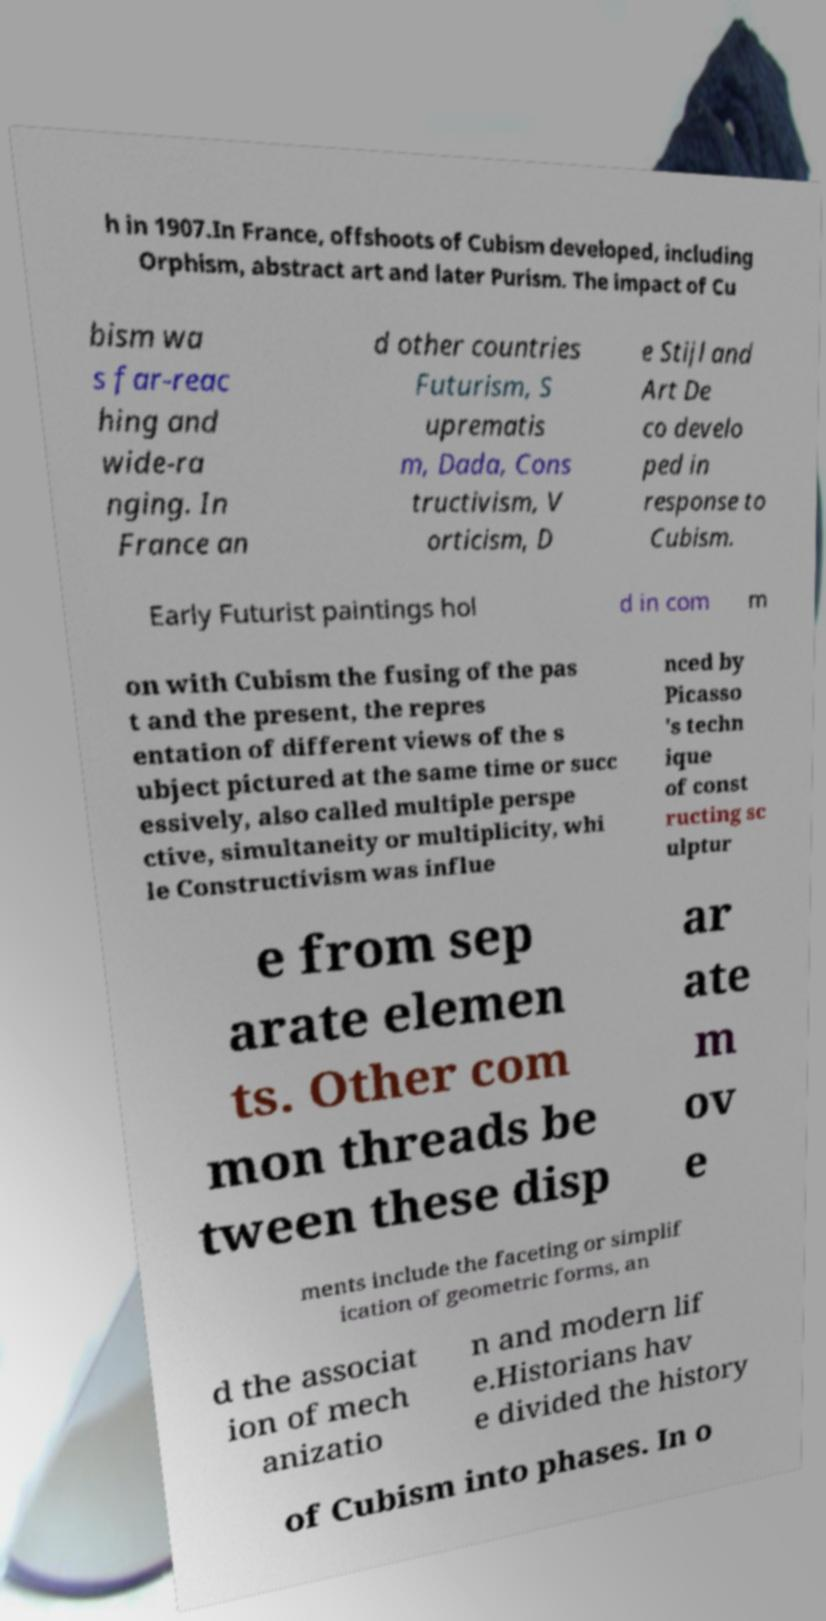Could you extract and type out the text from this image? h in 1907.In France, offshoots of Cubism developed, including Orphism, abstract art and later Purism. The impact of Cu bism wa s far-reac hing and wide-ra nging. In France an d other countries Futurism, S uprematis m, Dada, Cons tructivism, V orticism, D e Stijl and Art De co develo ped in response to Cubism. Early Futurist paintings hol d in com m on with Cubism the fusing of the pas t and the present, the repres entation of different views of the s ubject pictured at the same time or succ essively, also called multiple perspe ctive, simultaneity or multiplicity, whi le Constructivism was influe nced by Picasso 's techn ique of const ructing sc ulptur e from sep arate elemen ts. Other com mon threads be tween these disp ar ate m ov e ments include the faceting or simplif ication of geometric forms, an d the associat ion of mech anizatio n and modern lif e.Historians hav e divided the history of Cubism into phases. In o 